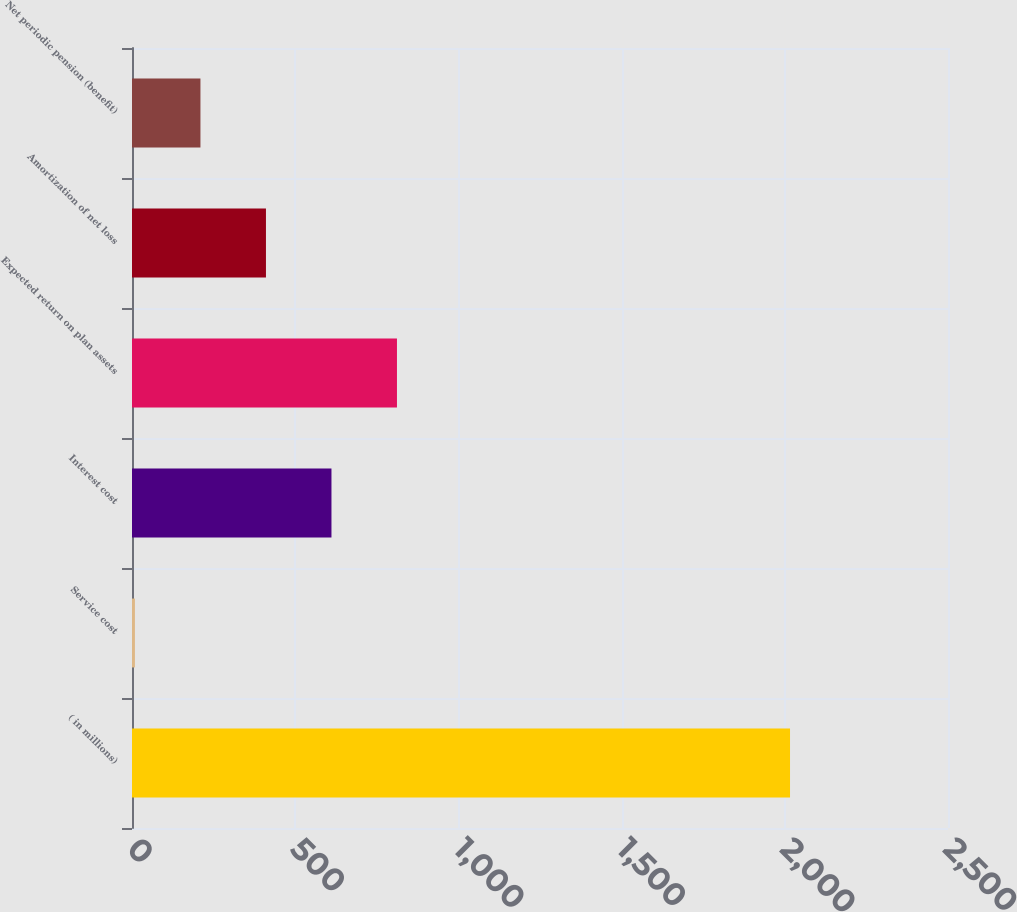<chart> <loc_0><loc_0><loc_500><loc_500><bar_chart><fcel>( in millions)<fcel>Service cost<fcel>Interest cost<fcel>Expected return on plan assets<fcel>Amortization of net loss<fcel>Net periodic pension (benefit)<nl><fcel>2016<fcel>9<fcel>611.1<fcel>811.8<fcel>410.4<fcel>209.7<nl></chart> 